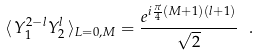<formula> <loc_0><loc_0><loc_500><loc_500>\langle \, Y _ { 1 } ^ { 2 - l } Y _ { 2 } ^ { l } \, \rangle _ { L = 0 , M } = \frac { e ^ { i \frac { \pi } { 4 } ( M + 1 ) ( l + 1 ) } } { \sqrt { 2 } } \ .</formula> 